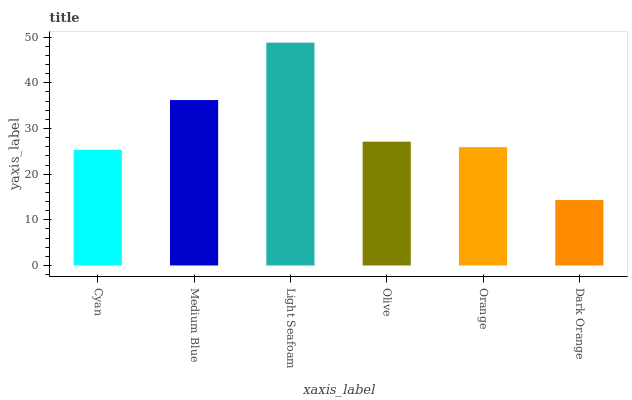Is Dark Orange the minimum?
Answer yes or no. Yes. Is Light Seafoam the maximum?
Answer yes or no. Yes. Is Medium Blue the minimum?
Answer yes or no. No. Is Medium Blue the maximum?
Answer yes or no. No. Is Medium Blue greater than Cyan?
Answer yes or no. Yes. Is Cyan less than Medium Blue?
Answer yes or no. Yes. Is Cyan greater than Medium Blue?
Answer yes or no. No. Is Medium Blue less than Cyan?
Answer yes or no. No. Is Olive the high median?
Answer yes or no. Yes. Is Orange the low median?
Answer yes or no. Yes. Is Orange the high median?
Answer yes or no. No. Is Olive the low median?
Answer yes or no. No. 